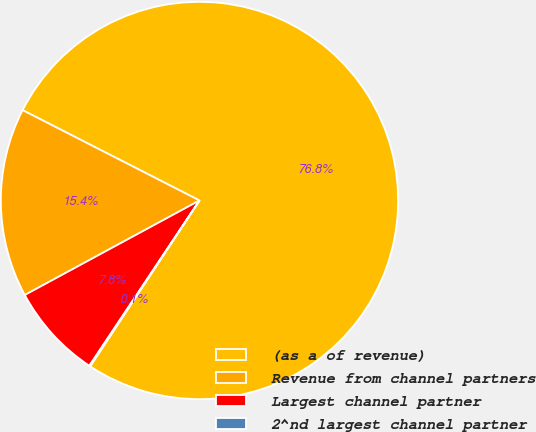Convert chart. <chart><loc_0><loc_0><loc_500><loc_500><pie_chart><fcel>(as a of revenue)<fcel>Revenue from channel partners<fcel>Largest channel partner<fcel>2^nd largest channel partner<nl><fcel>76.76%<fcel>15.41%<fcel>7.75%<fcel>0.08%<nl></chart> 